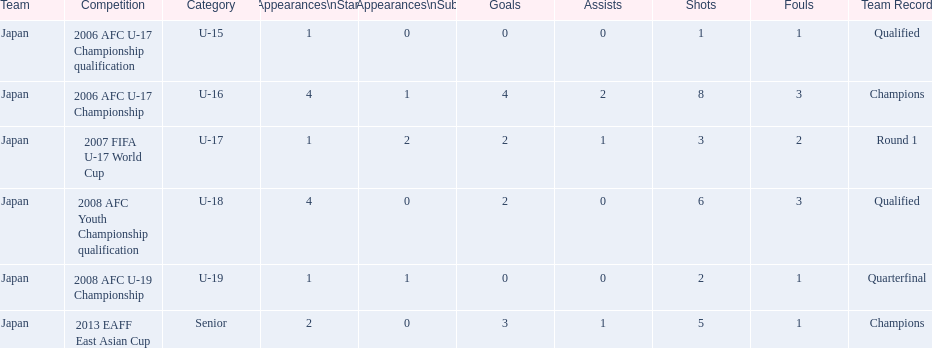What are all of the competitions? 2006 AFC U-17 Championship qualification, 2006 AFC U-17 Championship, 2007 FIFA U-17 World Cup, 2008 AFC Youth Championship qualification, 2008 AFC U-19 Championship, 2013 EAFF East Asian Cup. How many starting appearances were there? 1, 4, 1, 4, 1, 2. What about just during 2013 eaff east asian cup and 2007 fifa u-17 world cup? 1, 2. Which of those had more starting appearances? 2013 EAFF East Asian Cup. 